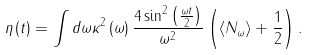Convert formula to latex. <formula><loc_0><loc_0><loc_500><loc_500>\eta \left ( t \right ) = \int d \omega \kappa ^ { 2 } \left ( \omega \right ) \frac { 4 \sin ^ { 2 } \left ( \frac { \omega t } 2 \right ) } { \omega ^ { 2 } } \left ( \left \langle N _ { \omega } \right \rangle + \frac { 1 } { 2 } \right ) .</formula> 